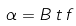Convert formula to latex. <formula><loc_0><loc_0><loc_500><loc_500>\alpha = B \, t \, f</formula> 